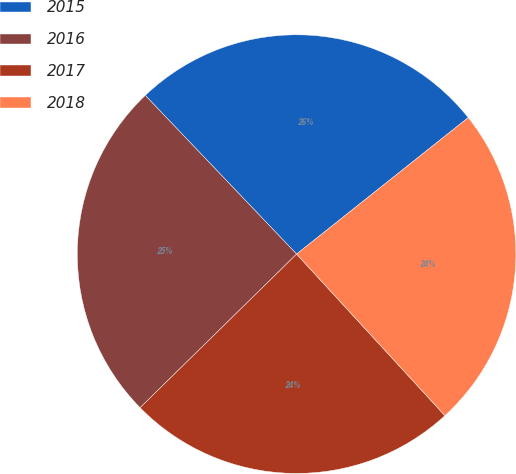<chart> <loc_0><loc_0><loc_500><loc_500><pie_chart><fcel>2015<fcel>2016<fcel>2017<fcel>2018<nl><fcel>26.43%<fcel>25.23%<fcel>24.47%<fcel>23.87%<nl></chart> 